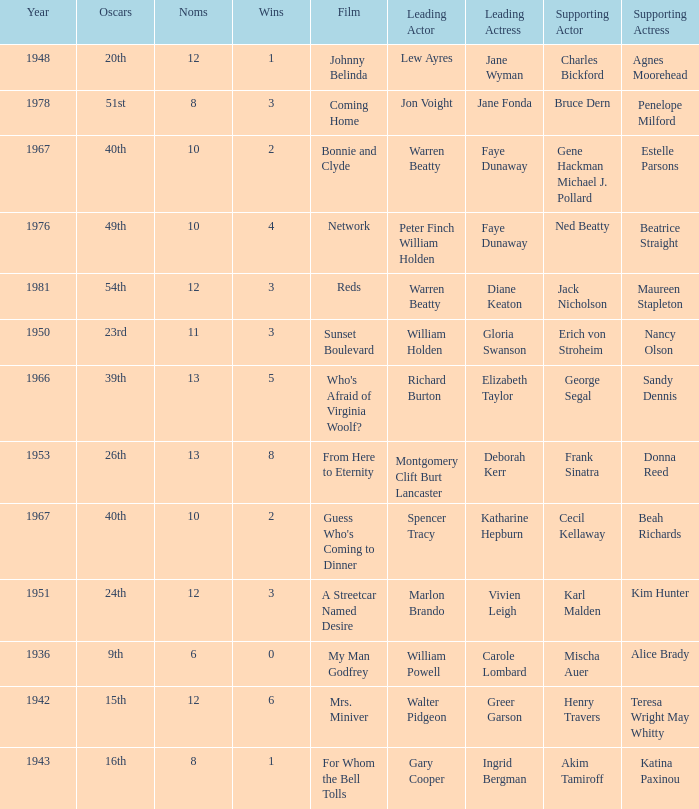In the movie featuring cecil kellaway as a supporting actor, who played the main role? Spencer Tracy. 